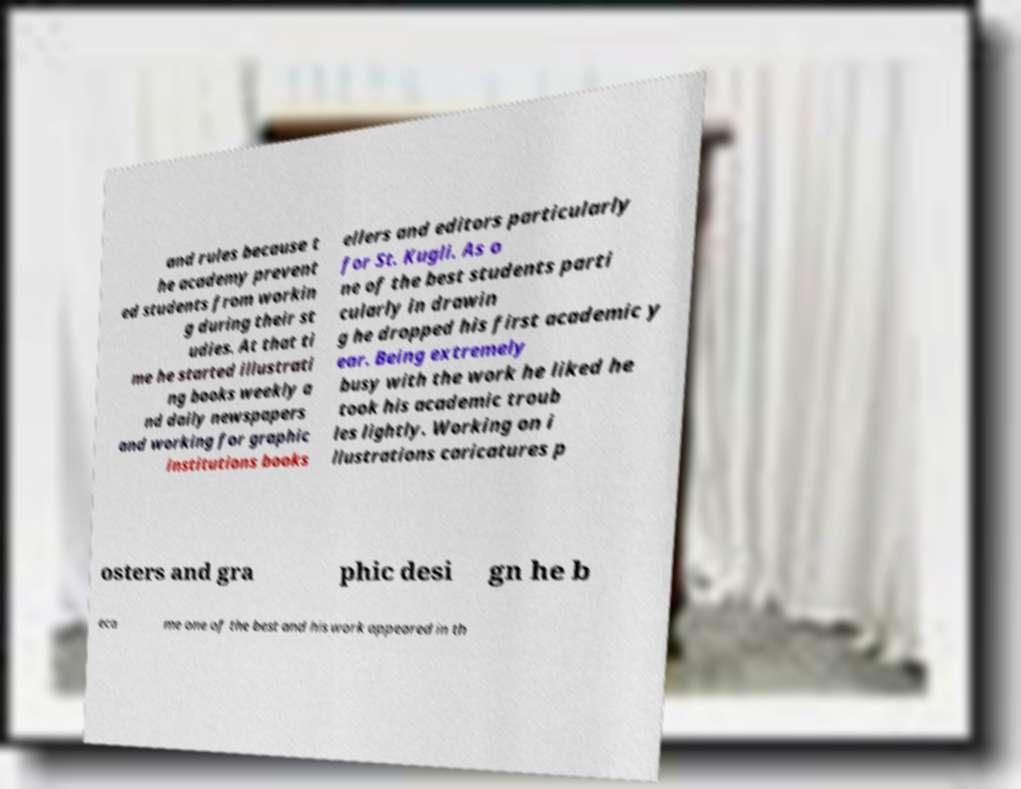Can you accurately transcribe the text from the provided image for me? and rules because t he academy prevent ed students from workin g during their st udies. At that ti me he started illustrati ng books weekly a nd daily newspapers and working for graphic institutions books ellers and editors particularly for St. Kugli. As o ne of the best students parti cularly in drawin g he dropped his first academic y ear. Being extremely busy with the work he liked he took his academic troub les lightly. Working on i llustrations caricatures p osters and gra phic desi gn he b eca me one of the best and his work appeared in th 